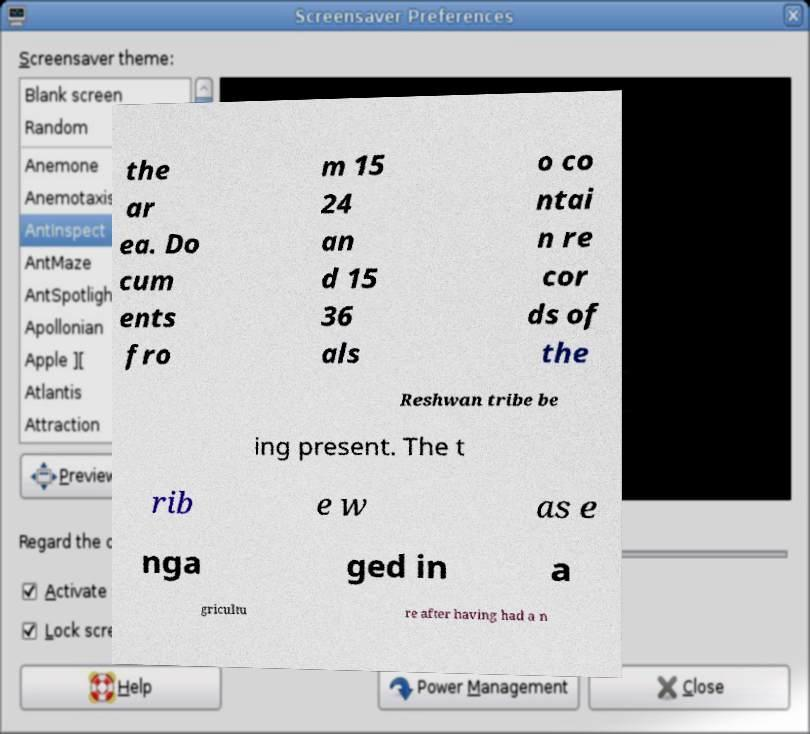Could you assist in decoding the text presented in this image and type it out clearly? the ar ea. Do cum ents fro m 15 24 an d 15 36 als o co ntai n re cor ds of the Reshwan tribe be ing present. The t rib e w as e nga ged in a gricultu re after having had a n 